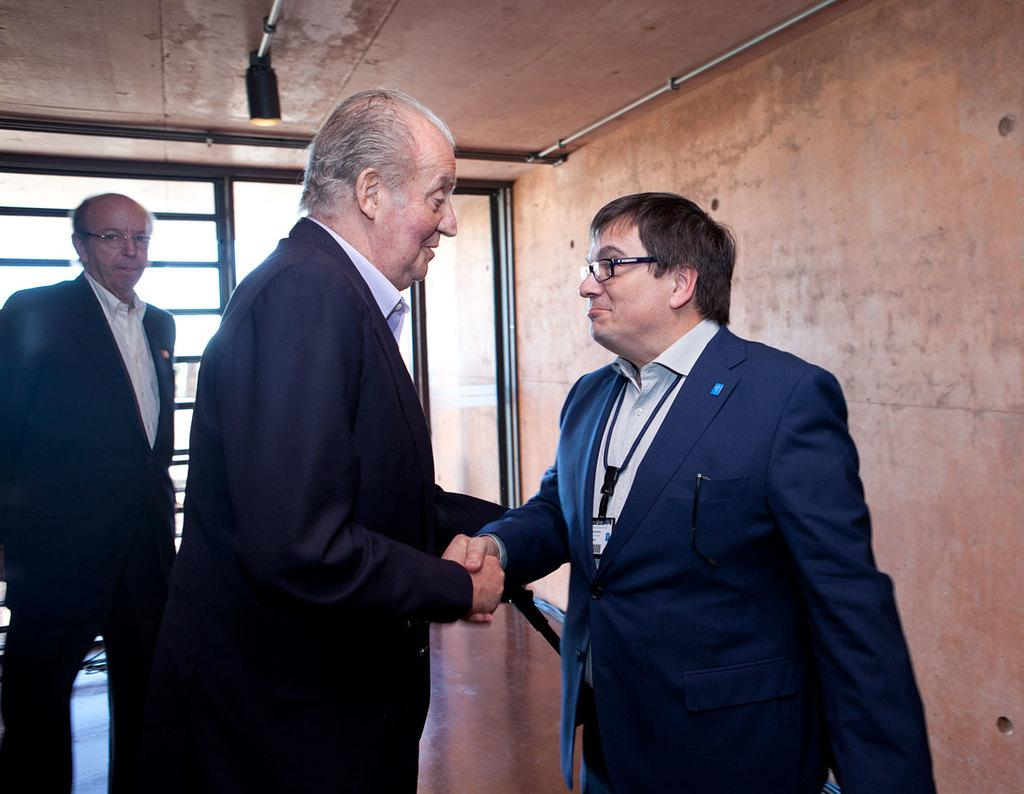What are the two men in the foreground of the image doing? The two men in the foreground of the image are shaking hands. Can you describe the man on the left side of the image? There is another man standing on the left side of the image. What can be seen in the background of the image? There is a wall, a floor, and a glass object visible in the background of the image. What type of egg is being used to organize the glass object in the image? There is no egg or organization of objects present in the image. 